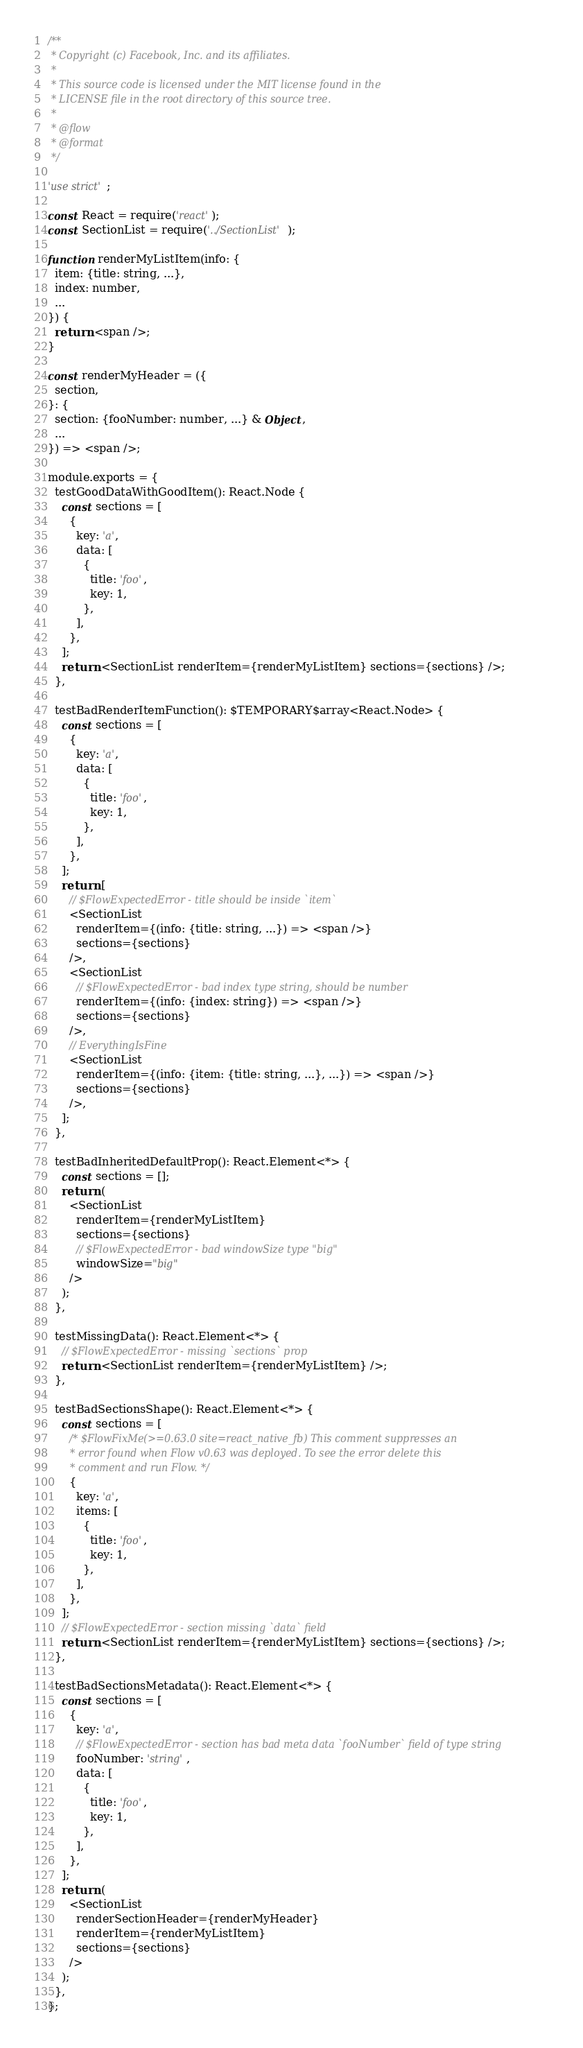<code> <loc_0><loc_0><loc_500><loc_500><_JavaScript_>/**
 * Copyright (c) Facebook, Inc. and its affiliates.
 *
 * This source code is licensed under the MIT license found in the
 * LICENSE file in the root directory of this source tree.
 *
 * @flow
 * @format
 */

'use strict';

const React = require('react');
const SectionList = require('../SectionList');

function renderMyListItem(info: {
  item: {title: string, ...},
  index: number,
  ...
}) {
  return <span />;
}

const renderMyHeader = ({
  section,
}: {
  section: {fooNumber: number, ...} & Object,
  ...
}) => <span />;

module.exports = {
  testGoodDataWithGoodItem(): React.Node {
    const sections = [
      {
        key: 'a',
        data: [
          {
            title: 'foo',
            key: 1,
          },
        ],
      },
    ];
    return <SectionList renderItem={renderMyListItem} sections={sections} />;
  },

  testBadRenderItemFunction(): $TEMPORARY$array<React.Node> {
    const sections = [
      {
        key: 'a',
        data: [
          {
            title: 'foo',
            key: 1,
          },
        ],
      },
    ];
    return [
      // $FlowExpectedError - title should be inside `item`
      <SectionList
        renderItem={(info: {title: string, ...}) => <span />}
        sections={sections}
      />,
      <SectionList
        // $FlowExpectedError - bad index type string, should be number
        renderItem={(info: {index: string}) => <span />}
        sections={sections}
      />,
      // EverythingIsFine
      <SectionList
        renderItem={(info: {item: {title: string, ...}, ...}) => <span />}
        sections={sections}
      />,
    ];
  },

  testBadInheritedDefaultProp(): React.Element<*> {
    const sections = [];
    return (
      <SectionList
        renderItem={renderMyListItem}
        sections={sections}
        // $FlowExpectedError - bad windowSize type "big"
        windowSize="big"
      />
    );
  },

  testMissingData(): React.Element<*> {
    // $FlowExpectedError - missing `sections` prop
    return <SectionList renderItem={renderMyListItem} />;
  },

  testBadSectionsShape(): React.Element<*> {
    const sections = [
      /* $FlowFixMe(>=0.63.0 site=react_native_fb) This comment suppresses an
       * error found when Flow v0.63 was deployed. To see the error delete this
       * comment and run Flow. */
      {
        key: 'a',
        items: [
          {
            title: 'foo',
            key: 1,
          },
        ],
      },
    ];
    // $FlowExpectedError - section missing `data` field
    return <SectionList renderItem={renderMyListItem} sections={sections} />;
  },

  testBadSectionsMetadata(): React.Element<*> {
    const sections = [
      {
        key: 'a',
        // $FlowExpectedError - section has bad meta data `fooNumber` field of type string
        fooNumber: 'string',
        data: [
          {
            title: 'foo',
            key: 1,
          },
        ],
      },
    ];
    return (
      <SectionList
        renderSectionHeader={renderMyHeader}
        renderItem={renderMyListItem}
        sections={sections}
      />
    );
  },
};
</code> 